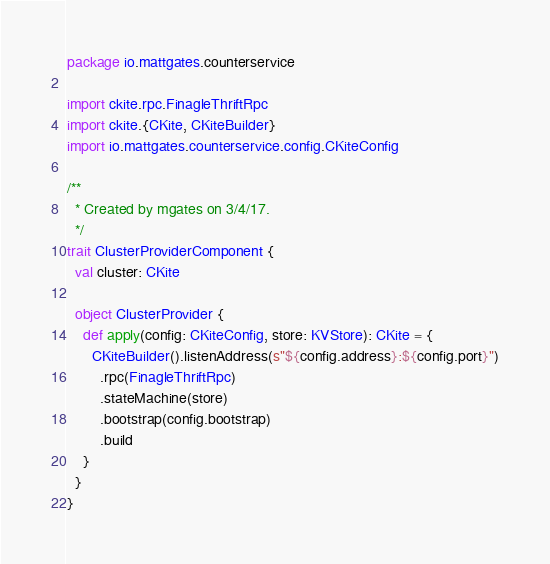Convert code to text. <code><loc_0><loc_0><loc_500><loc_500><_Scala_>package io.mattgates.counterservice

import ckite.rpc.FinagleThriftRpc
import ckite.{CKite, CKiteBuilder}
import io.mattgates.counterservice.config.CKiteConfig

/**
  * Created by mgates on 3/4/17.
  */
trait ClusterProviderComponent {
  val cluster: CKite

  object ClusterProvider {
    def apply(config: CKiteConfig, store: KVStore): CKite = {
      CKiteBuilder().listenAddress(s"${config.address}:${config.port}")
        .rpc(FinagleThriftRpc)
        .stateMachine(store)
        .bootstrap(config.bootstrap)
        .build
    }
  }
}
</code> 